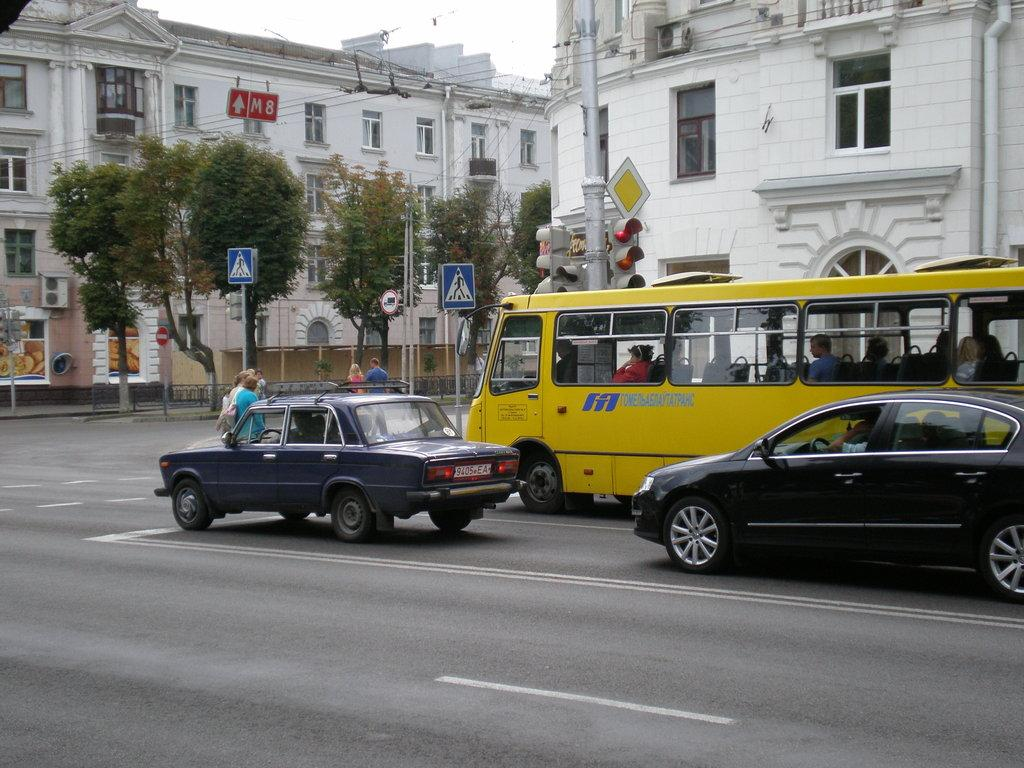What is happening on the road in the image? There are cars moving on the road in the image. Who or what can be seen in the image besides the cars? There are persons in the image. What can be seen in the distance in the image? There are buildings, poles, and trees in the background of the image. How would you describe the weather in the image? The sky is cloudy in the image. Is there a beggar asking for money in the image? There is no mention of a beggar in the provided facts, so we cannot confirm or deny their presence in the image. 